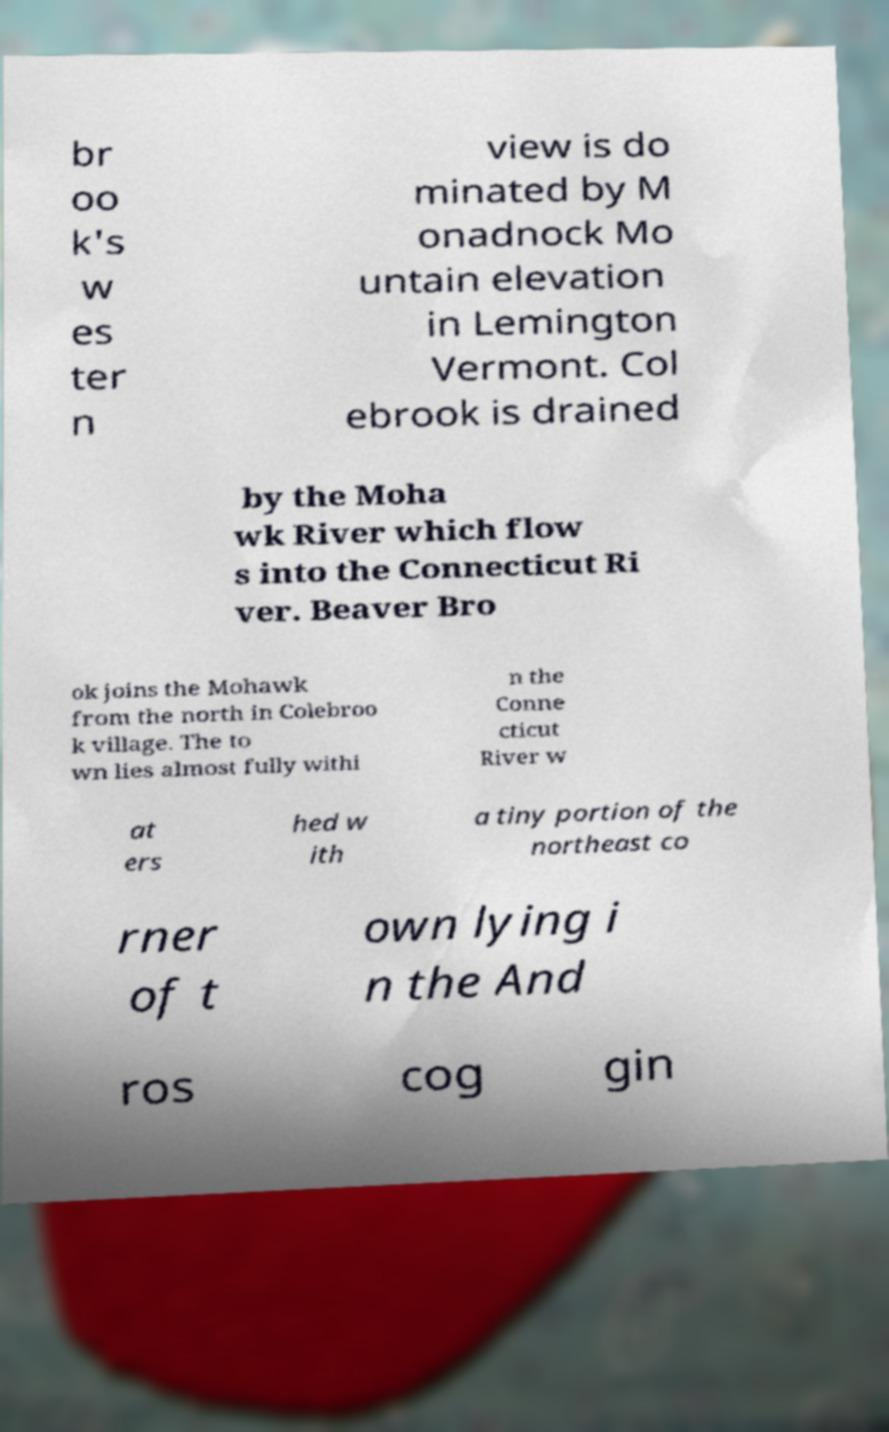What messages or text are displayed in this image? I need them in a readable, typed format. br oo k's w es ter n view is do minated by M onadnock Mo untain elevation in Lemington Vermont. Col ebrook is drained by the Moha wk River which flow s into the Connecticut Ri ver. Beaver Bro ok joins the Mohawk from the north in Colebroo k village. The to wn lies almost fully withi n the Conne cticut River w at ers hed w ith a tiny portion of the northeast co rner of t own lying i n the And ros cog gin 